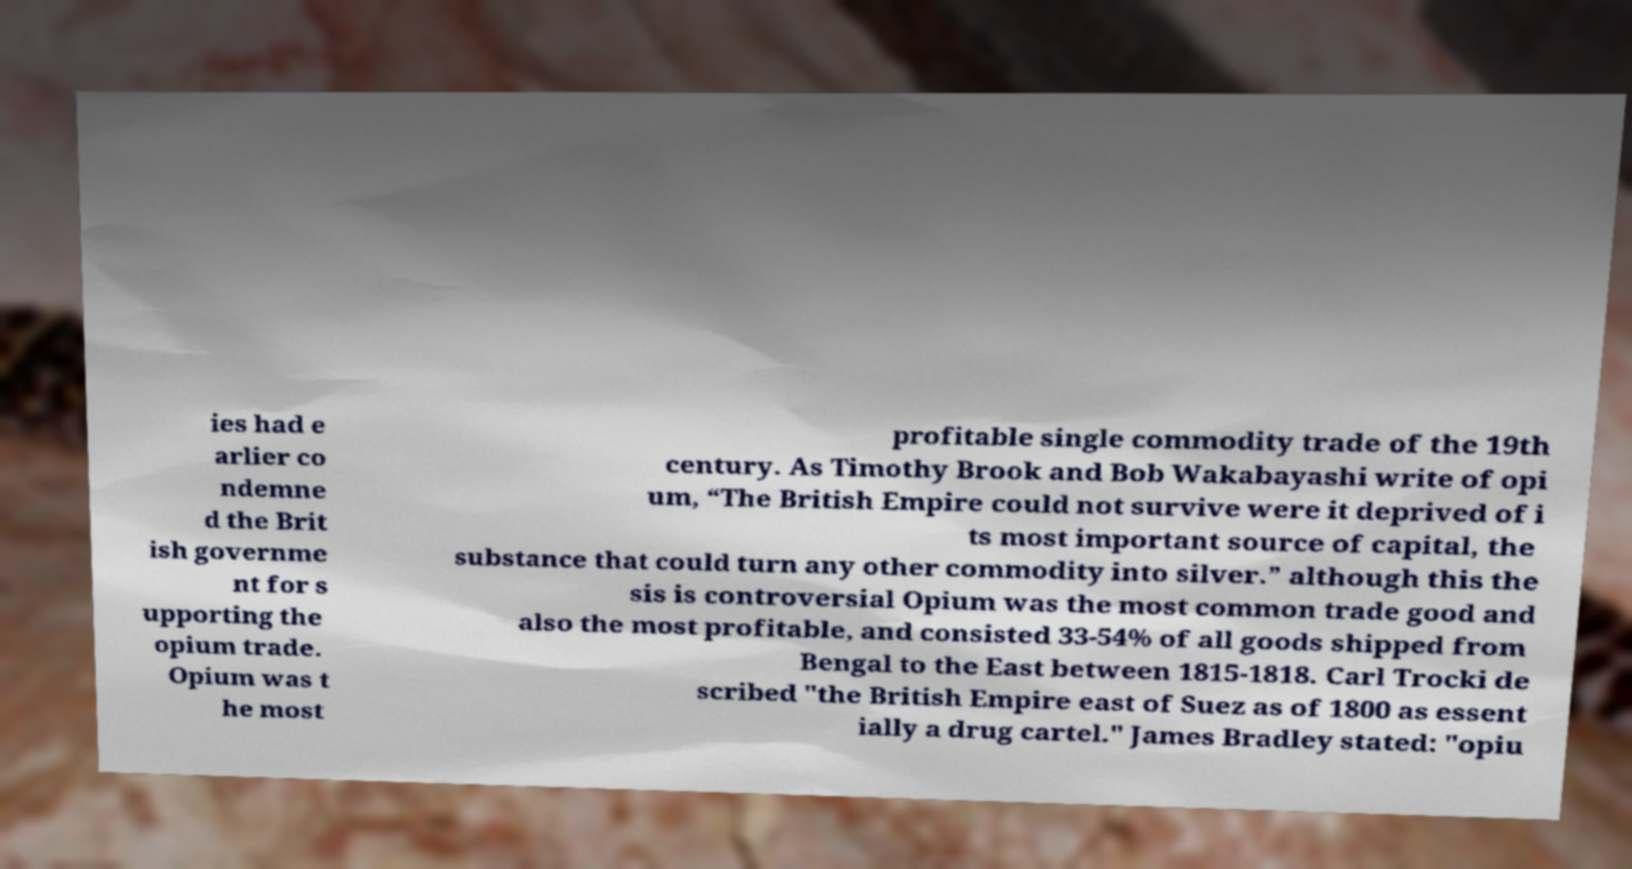Can you accurately transcribe the text from the provided image for me? ies had e arlier co ndemne d the Brit ish governme nt for s upporting the opium trade. Opium was t he most profitable single commodity trade of the 19th century. As Timothy Brook and Bob Wakabayashi write of opi um, “The British Empire could not survive were it deprived of i ts most important source of capital, the substance that could turn any other commodity into silver.” although this the sis is controversial Opium was the most common trade good and also the most profitable, and consisted 33-54% of all goods shipped from Bengal to the East between 1815-1818. Carl Trocki de scribed "the British Empire east of Suez as of 1800 as essent ially a drug cartel." James Bradley stated: "opiu 